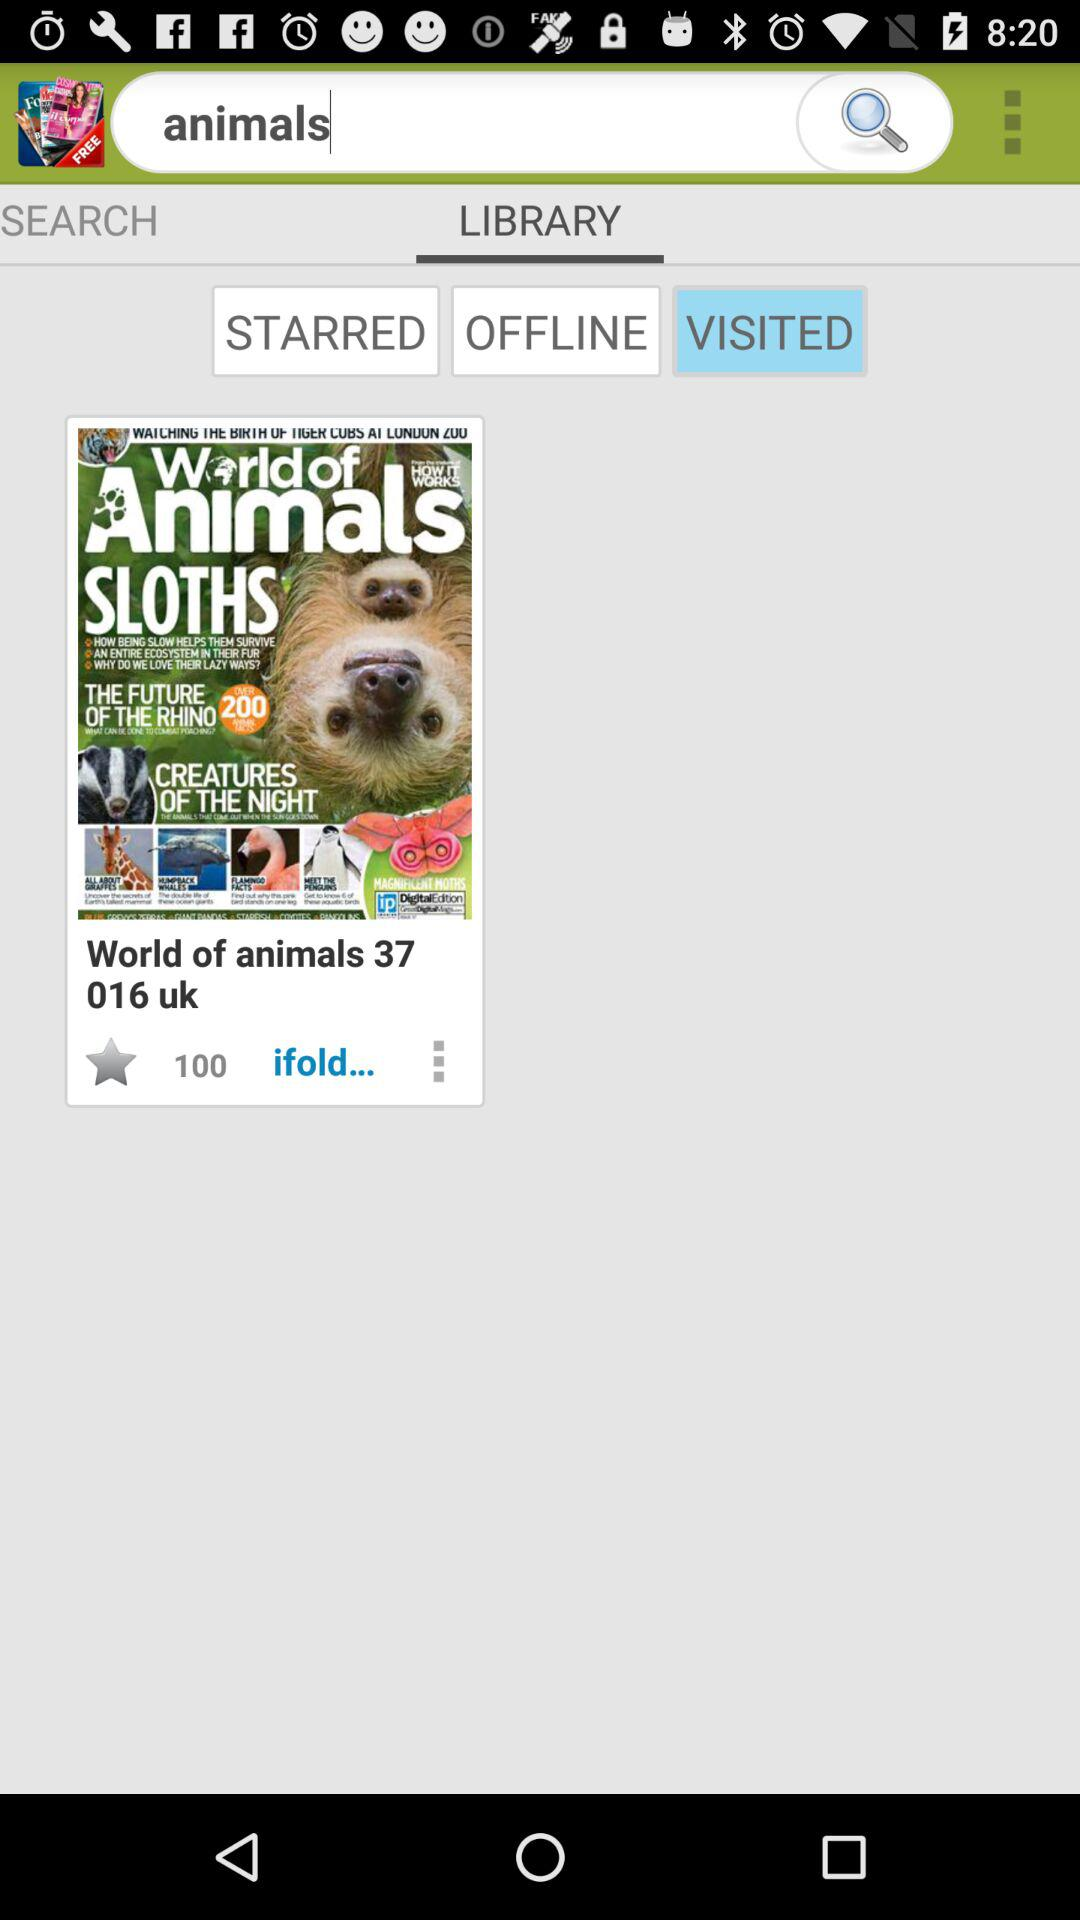How many star ratings does the article have?
Answer the question using a single word or phrase. 100 